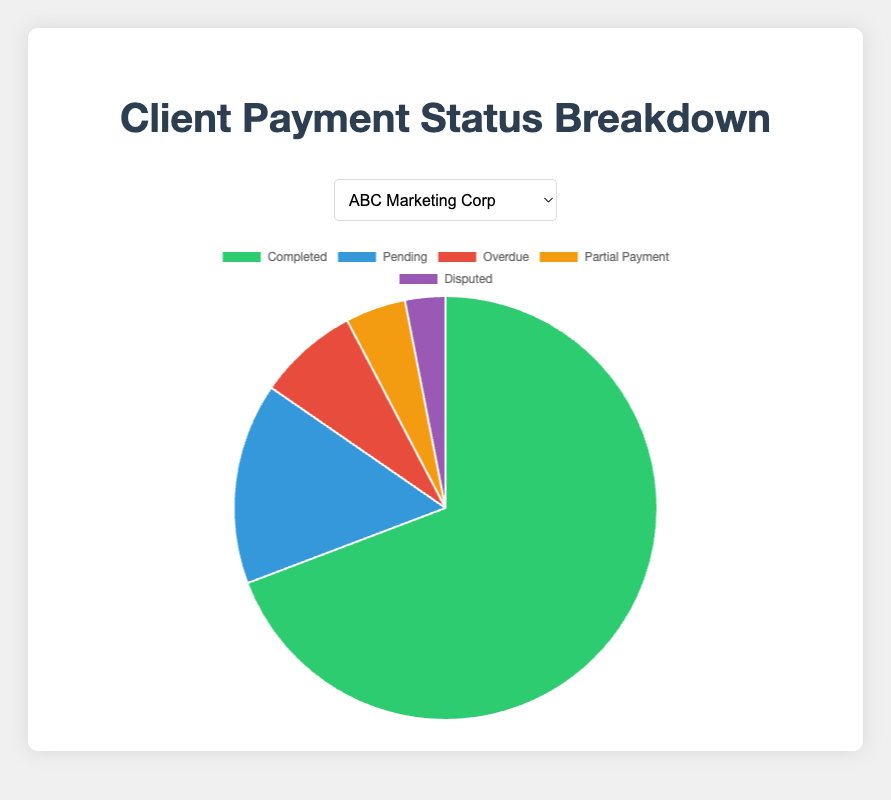What's the maximum number of overdue payments observed across clients? In the pie charts for the five clients, we look for the highest "Overdue" value. The values are: 5 for ABC Marketing Corp, 4 for XYZ Fashion Studio, 7 for Global Media Group, 6 for FreshFoods Ltd., and 3 for Urban Lifestyle Magazine. The highest amount is 7.
Answer: 7 Which client has the least amount of payments pending? From the pie charts, the pending payments for each client are: 10 for ABC Marketing Corp, 12 for XYZ Fashion Studio, 9 for Global Media Group, 18 for FreshFoods Ltd., and 7 for Urban Lifestyle Magazine. The least is 7, attributed to Urban Lifestyle Magazine.
Answer: Urban Lifestyle Magazine Is there a client with no disputed payments? By checking the pie chart, we find that Urban Lifestyle Magazine has 0 disputed payments. All other clients have some disputed payments.
Answer: Urban Lifestyle Magazine Which client has the highest percentage of completed payments? Calculate the percentage of completed payments for each client:
- ABC Marketing Corp: 45/(45+10+5+3+2) ≈ 72.58%
- XYZ Fashion Studio: 50/(50+12+4+6+1) ≈ 69.44%
- Global Media Group: 60/(60+9+7+8+2) ≈ 67.42%
- FreshFoods Ltd.: 40/(40+18+6+4+3) ≈ 53.33%
- Urban Lifestyle Magazine: 55/(55+7+3+1+0) ≈ 83.33%
The highest percentage is for Urban Lifestyle Magazine at approximately 83.33%.
Answer: Urban Lifestyle Magazine How many clients have more than 5 overdue payments? The pie charts show the number of overdue payments for each client: 5 for ABC Marketing Corp, 4 for XYZ Fashion Studio, 7 for Global Media Group, 6 for FreshFoods Ltd., and 3 for Urban Lifestyle Magazine. Two clients have more than 5 overdue payments: Global Media Group and FreshFoods Ltd.
Answer: 2 